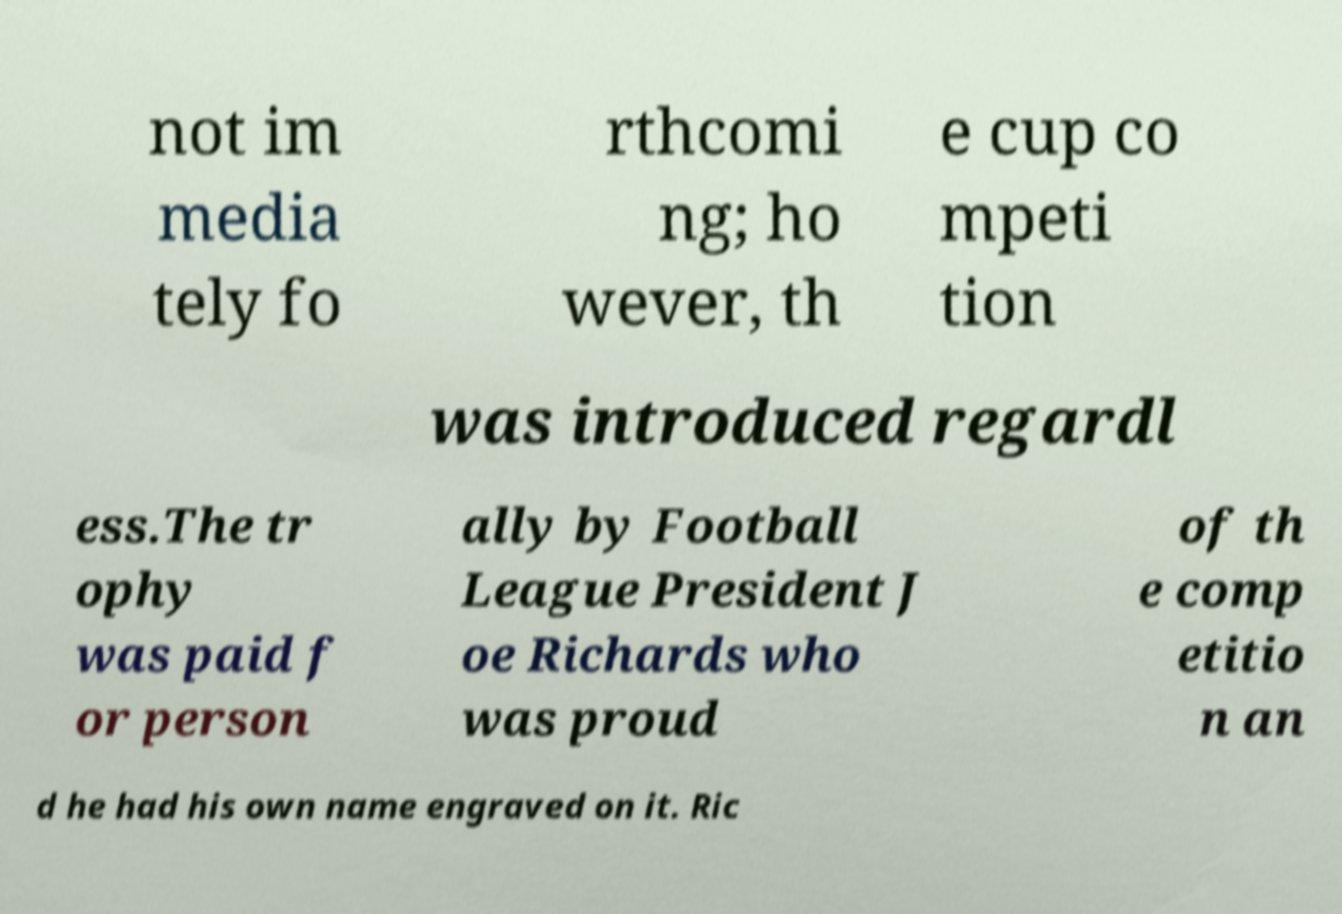Can you read and provide the text displayed in the image?This photo seems to have some interesting text. Can you extract and type it out for me? not im media tely fo rthcomi ng; ho wever, th e cup co mpeti tion was introduced regardl ess.The tr ophy was paid f or person ally by Football League President J oe Richards who was proud of th e comp etitio n an d he had his own name engraved on it. Ric 